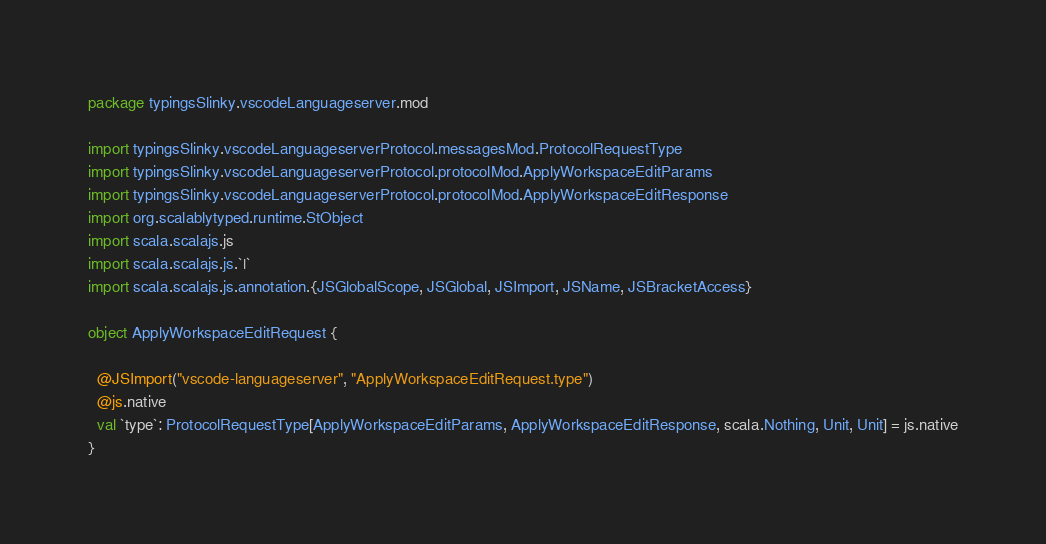Convert code to text. <code><loc_0><loc_0><loc_500><loc_500><_Scala_>package typingsSlinky.vscodeLanguageserver.mod

import typingsSlinky.vscodeLanguageserverProtocol.messagesMod.ProtocolRequestType
import typingsSlinky.vscodeLanguageserverProtocol.protocolMod.ApplyWorkspaceEditParams
import typingsSlinky.vscodeLanguageserverProtocol.protocolMod.ApplyWorkspaceEditResponse
import org.scalablytyped.runtime.StObject
import scala.scalajs.js
import scala.scalajs.js.`|`
import scala.scalajs.js.annotation.{JSGlobalScope, JSGlobal, JSImport, JSName, JSBracketAccess}

object ApplyWorkspaceEditRequest {
  
  @JSImport("vscode-languageserver", "ApplyWorkspaceEditRequest.type")
  @js.native
  val `type`: ProtocolRequestType[ApplyWorkspaceEditParams, ApplyWorkspaceEditResponse, scala.Nothing, Unit, Unit] = js.native
}
</code> 